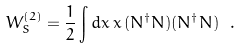Convert formula to latex. <formula><loc_0><loc_0><loc_500><loc_500>W _ { S } ^ { ( 2 ) } = \frac { 1 } { 2 } \int d { x } \, { x } \, ( N ^ { \dagger } N ) ( N ^ { \dagger } N ) \ .</formula> 